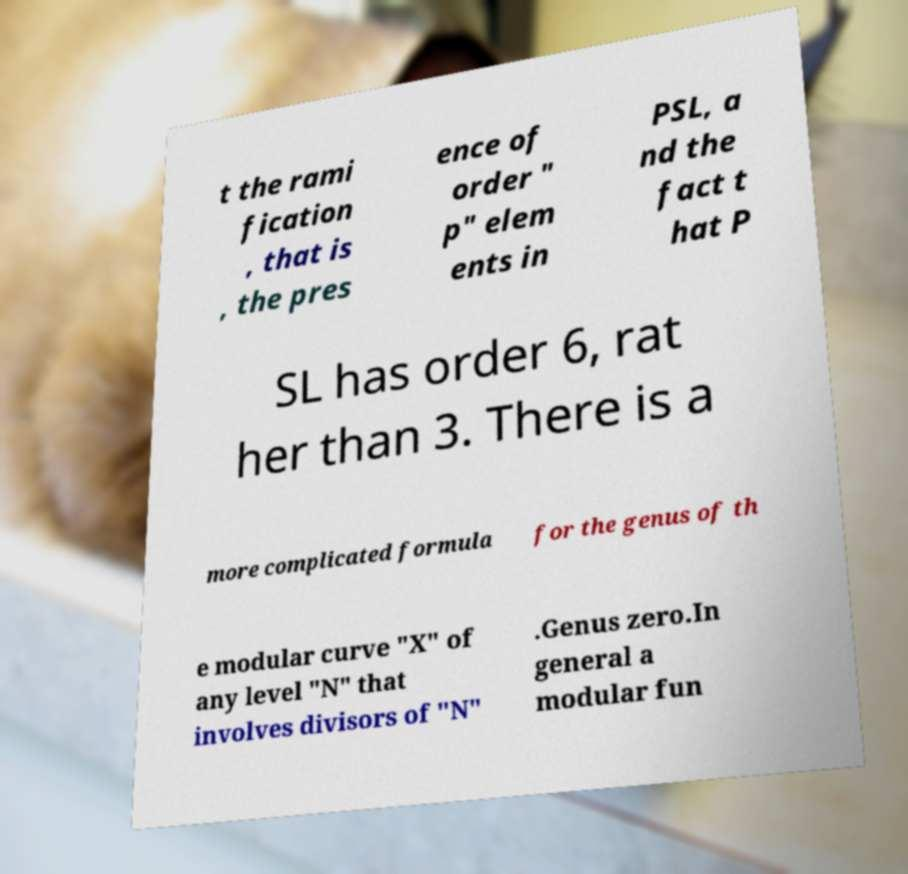Please read and relay the text visible in this image. What does it say? t the rami fication , that is , the pres ence of order " p" elem ents in PSL, a nd the fact t hat P SL has order 6, rat her than 3. There is a more complicated formula for the genus of th e modular curve "X" of any level "N" that involves divisors of "N" .Genus zero.In general a modular fun 